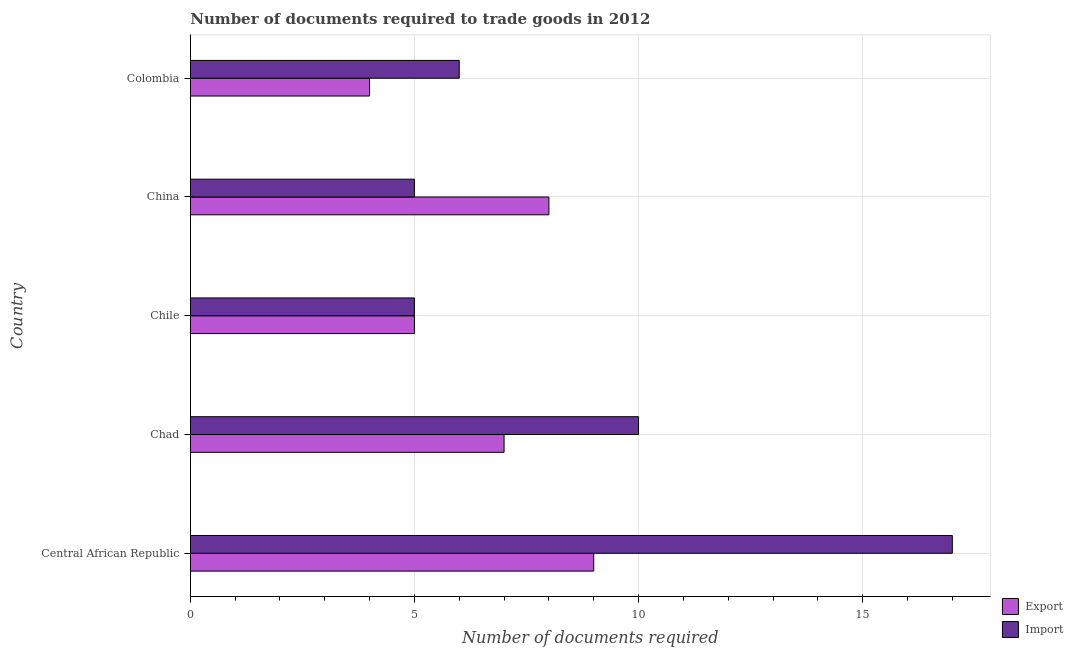Are the number of bars per tick equal to the number of legend labels?
Provide a succinct answer. Yes. How many bars are there on the 3rd tick from the top?
Your response must be concise. 2. How many bars are there on the 3rd tick from the bottom?
Your response must be concise. 2. What is the label of the 5th group of bars from the top?
Keep it short and to the point. Central African Republic. What is the number of documents required to import goods in Colombia?
Offer a terse response. 6. Across all countries, what is the maximum number of documents required to import goods?
Keep it short and to the point. 17. In which country was the number of documents required to import goods maximum?
Your answer should be very brief. Central African Republic. What is the difference between the number of documents required to export goods in Central African Republic and the number of documents required to import goods in Chile?
Make the answer very short. 4. What is the difference between the number of documents required to import goods and number of documents required to export goods in Colombia?
Keep it short and to the point. 2. In how many countries, is the number of documents required to export goods greater than 7 ?
Make the answer very short. 2. What is the ratio of the number of documents required to export goods in Chile to that in China?
Make the answer very short. 0.62. Is the number of documents required to export goods in Chad less than that in China?
Offer a very short reply. Yes. What does the 1st bar from the top in China represents?
Make the answer very short. Import. What does the 1st bar from the bottom in Central African Republic represents?
Your response must be concise. Export. Are all the bars in the graph horizontal?
Your answer should be very brief. Yes. What is the difference between two consecutive major ticks on the X-axis?
Your answer should be very brief. 5. Does the graph contain grids?
Ensure brevity in your answer.  Yes. Where does the legend appear in the graph?
Make the answer very short. Bottom right. How are the legend labels stacked?
Offer a very short reply. Vertical. What is the title of the graph?
Give a very brief answer. Number of documents required to trade goods in 2012. What is the label or title of the X-axis?
Offer a terse response. Number of documents required. What is the Number of documents required of Import in Central African Republic?
Offer a terse response. 17. What is the Number of documents required of Import in Chad?
Provide a short and direct response. 10. What is the Number of documents required of Import in China?
Your answer should be compact. 5. What is the Number of documents required of Export in Colombia?
Offer a terse response. 4. What is the Number of documents required of Import in Colombia?
Offer a very short reply. 6. Across all countries, what is the maximum Number of documents required in Export?
Provide a succinct answer. 9. Across all countries, what is the maximum Number of documents required in Import?
Your answer should be compact. 17. Across all countries, what is the minimum Number of documents required of Import?
Provide a succinct answer. 5. What is the total Number of documents required of Export in the graph?
Offer a terse response. 33. What is the total Number of documents required in Import in the graph?
Your answer should be compact. 43. What is the difference between the Number of documents required in Export in Central African Republic and that in Chad?
Offer a terse response. 2. What is the difference between the Number of documents required of Import in Central African Republic and that in Chile?
Offer a terse response. 12. What is the difference between the Number of documents required of Export in Central African Republic and that in China?
Keep it short and to the point. 1. What is the difference between the Number of documents required in Export in Central African Republic and that in Colombia?
Make the answer very short. 5. What is the difference between the Number of documents required in Import in Central African Republic and that in Colombia?
Provide a short and direct response. 11. What is the difference between the Number of documents required of Export in Chad and that in Chile?
Ensure brevity in your answer.  2. What is the difference between the Number of documents required of Export in Chad and that in China?
Offer a very short reply. -1. What is the difference between the Number of documents required of Import in Chad and that in China?
Provide a short and direct response. 5. What is the difference between the Number of documents required in Export in Chile and that in China?
Ensure brevity in your answer.  -3. What is the difference between the Number of documents required of Import in Chile and that in China?
Keep it short and to the point. 0. What is the difference between the Number of documents required in Import in China and that in Colombia?
Offer a terse response. -1. What is the difference between the Number of documents required in Export in Central African Republic and the Number of documents required in Import in Chile?
Your answer should be very brief. 4. What is the difference between the Number of documents required in Export in Chile and the Number of documents required in Import in China?
Your answer should be very brief. 0. What is the average Number of documents required in Export per country?
Provide a short and direct response. 6.6. What is the difference between the Number of documents required in Export and Number of documents required in Import in Chad?
Offer a very short reply. -3. What is the difference between the Number of documents required of Export and Number of documents required of Import in China?
Your answer should be compact. 3. What is the difference between the Number of documents required in Export and Number of documents required in Import in Colombia?
Give a very brief answer. -2. What is the ratio of the Number of documents required of Export in Central African Republic to that in Chad?
Offer a terse response. 1.29. What is the ratio of the Number of documents required of Import in Central African Republic to that in China?
Make the answer very short. 3.4. What is the ratio of the Number of documents required in Export in Central African Republic to that in Colombia?
Make the answer very short. 2.25. What is the ratio of the Number of documents required of Import in Central African Republic to that in Colombia?
Your response must be concise. 2.83. What is the ratio of the Number of documents required in Export in Chad to that in Chile?
Make the answer very short. 1.4. What is the ratio of the Number of documents required in Import in Chad to that in Chile?
Your answer should be compact. 2. What is the ratio of the Number of documents required in Export in Chad to that in China?
Your answer should be compact. 0.88. What is the ratio of the Number of documents required of Import in Chad to that in China?
Ensure brevity in your answer.  2. What is the ratio of the Number of documents required of Export in Chile to that in China?
Your answer should be very brief. 0.62. What is the ratio of the Number of documents required of Import in Chile to that in China?
Keep it short and to the point. 1. What is the difference between the highest and the second highest Number of documents required in Export?
Make the answer very short. 1. What is the difference between the highest and the second highest Number of documents required of Import?
Offer a terse response. 7. What is the difference between the highest and the lowest Number of documents required of Export?
Offer a terse response. 5. 